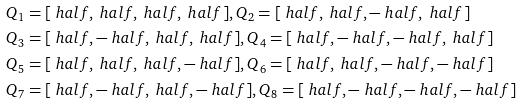Convert formula to latex. <formula><loc_0><loc_0><loc_500><loc_500>& Q _ { 1 } = [ \ h a l f , \ h a l f , \ h a l f , \ h a l f ] , Q _ { 2 } = [ \ h a l f , \ h a l f , - \ h a l f , \ h a l f ] \\ & Q _ { 3 } = [ \ h a l f , - \ h a l f , \ h a l f , \ h a l f ] , Q _ { 4 } = [ \ h a l f , - \ h a l f , - \ h a l f , \ h a l f ] \\ & Q _ { 5 } = [ \ h a l f , \ h a l f , \ h a l f , - \ h a l f ] , Q _ { 6 } = [ \ h a l f , \ h a l f , - \ h a l f , - \ h a l f ] \\ & Q _ { 7 } = [ \ h a l f , - \ h a l f , \ h a l f , - \ h a l f ] , Q _ { 8 } = [ \ h a l f , - \ h a l f , - \ h a l f , - \ h a l f ]</formula> 